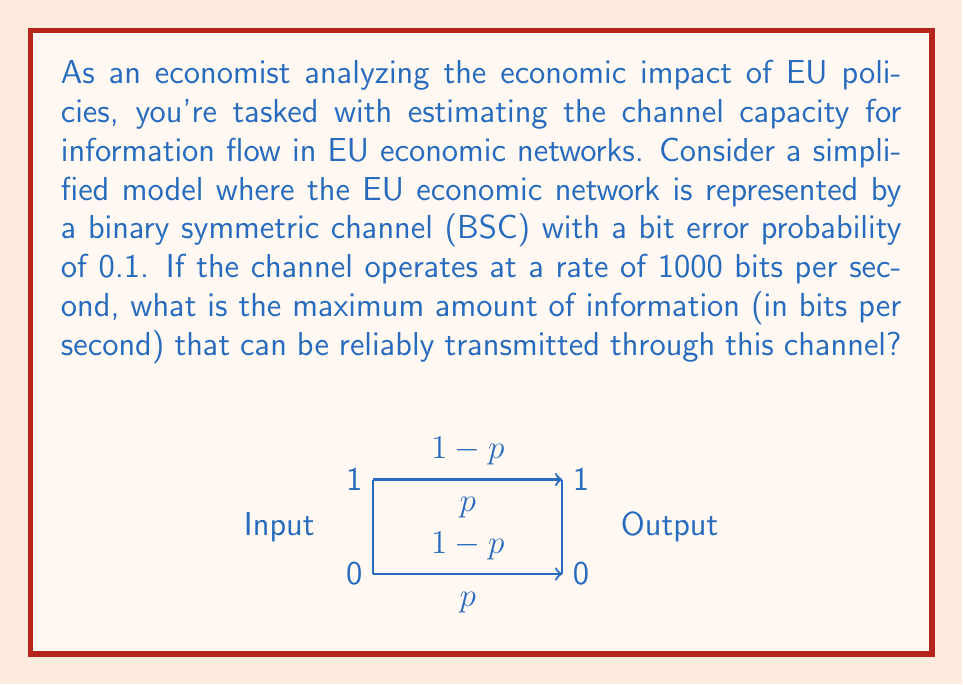Could you help me with this problem? To solve this problem, we'll use the concept of channel capacity from information theory. For a binary symmetric channel (BSC), the channel capacity is given by:

$$C = 1 - H(p)$$

where $C$ is the channel capacity in bits per channel use, and $H(p)$ is the binary entropy function:

$$H(p) = -p \log_2(p) - (1-p) \log_2(1-p)$$

Given:
- Bit error probability $p = 0.1$
- Channel operates at 1000 bits per second

Step 1: Calculate $H(p)$
$$\begin{align}
H(0.1) &= -0.1 \log_2(0.1) - 0.9 \log_2(0.9) \\
&\approx 0.469 \text{ bits}
\end{align}$$

Step 2: Calculate the channel capacity per use
$$\begin{align}
C &= 1 - H(p) \\
&= 1 - 0.469 \\
&\approx 0.531 \text{ bits per channel use}
\end{align}$$

Step 3: Calculate the maximum information flow
Since the channel operates at 1000 bits per second, we multiply the capacity per use by 1000:

$$\text{Maximum information flow} = 0.531 \times 1000 \approx 531 \text{ bits per second}$$

This means that although the channel transmits 1000 bits per second, only about 531 bits of those can be guaranteed to be reliable information due to the noise in the channel.
Answer: 531 bits per second 